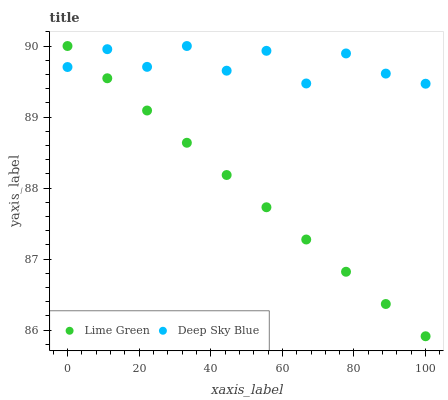Does Lime Green have the minimum area under the curve?
Answer yes or no. Yes. Does Deep Sky Blue have the maximum area under the curve?
Answer yes or no. Yes. Does Deep Sky Blue have the minimum area under the curve?
Answer yes or no. No. Is Lime Green the smoothest?
Answer yes or no. Yes. Is Deep Sky Blue the roughest?
Answer yes or no. Yes. Is Deep Sky Blue the smoothest?
Answer yes or no. No. Does Lime Green have the lowest value?
Answer yes or no. Yes. Does Deep Sky Blue have the lowest value?
Answer yes or no. No. Does Deep Sky Blue have the highest value?
Answer yes or no. Yes. Does Deep Sky Blue intersect Lime Green?
Answer yes or no. Yes. Is Deep Sky Blue less than Lime Green?
Answer yes or no. No. Is Deep Sky Blue greater than Lime Green?
Answer yes or no. No. 